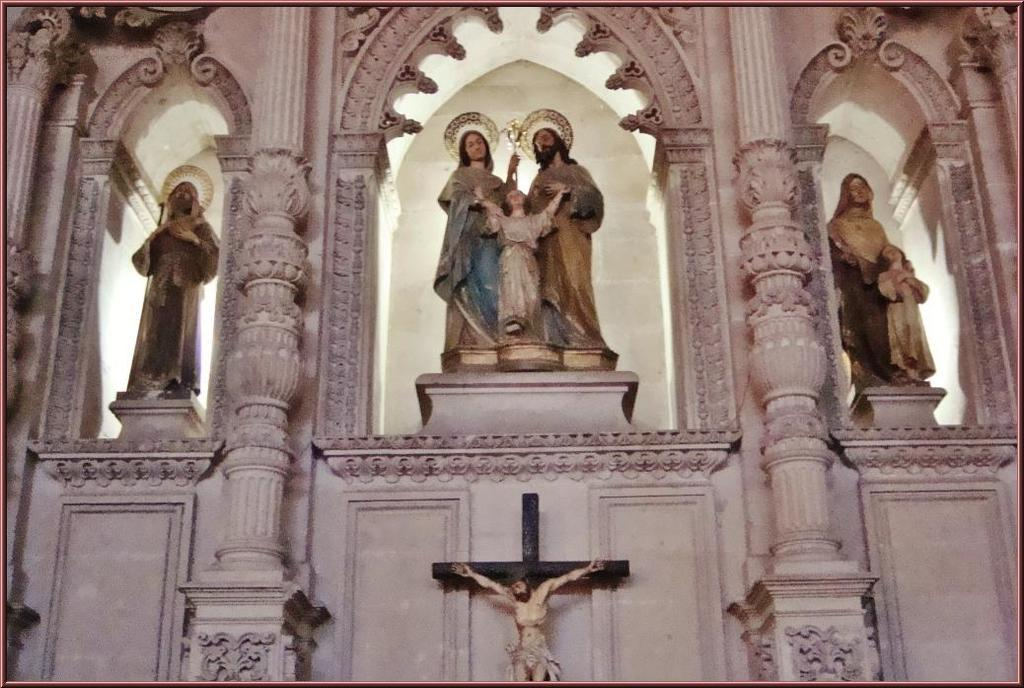What is depicted on the statue at the wall in the image? There is a statue of a person on a cross symbol at the wall. What can be seen on the platforms at the top of the image? There are statues of multiple persons on platforms at the top of the image. What architectural features are visible at the wall in the image? There are pillars visible at the wall. What type of stick is being used by the person in the image? There is no stick present in the image; it features statues of people. How many bottles can be seen in the image? There are no bottles present in the image. 